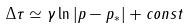Convert formula to latex. <formula><loc_0><loc_0><loc_500><loc_500>\Delta \tau \simeq \gamma \ln | p - p _ { * } | + c o n s t</formula> 